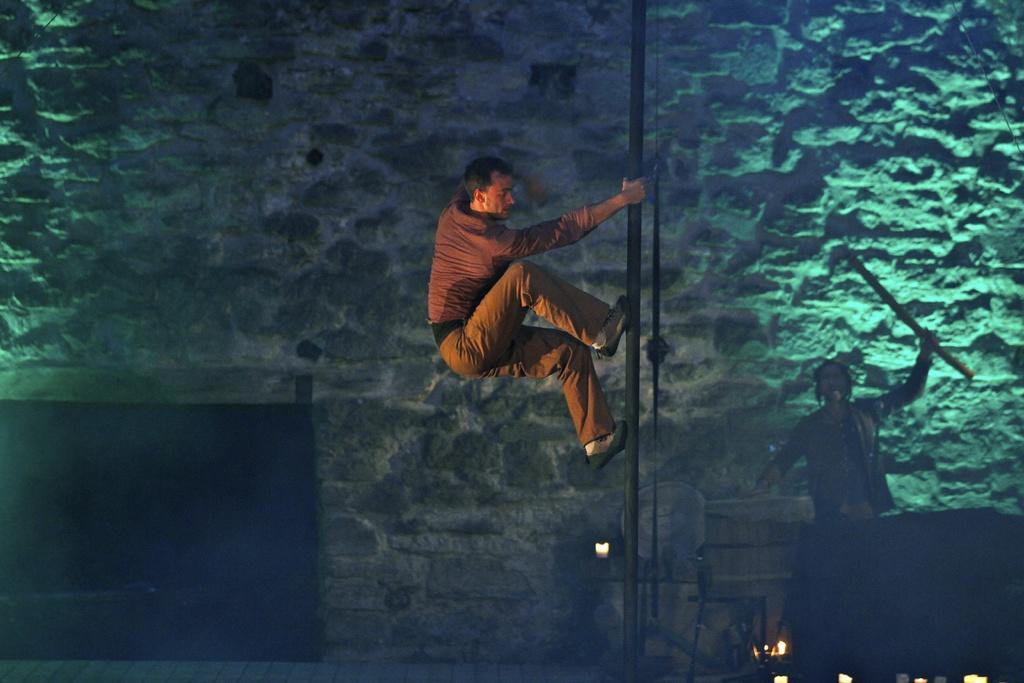Can you describe this image briefly? In this image, we can see a person holding and climbing a pole. In the background, there is a wall. On the right side of the image, we can see chair, rope, few objects and person holding a stick. 